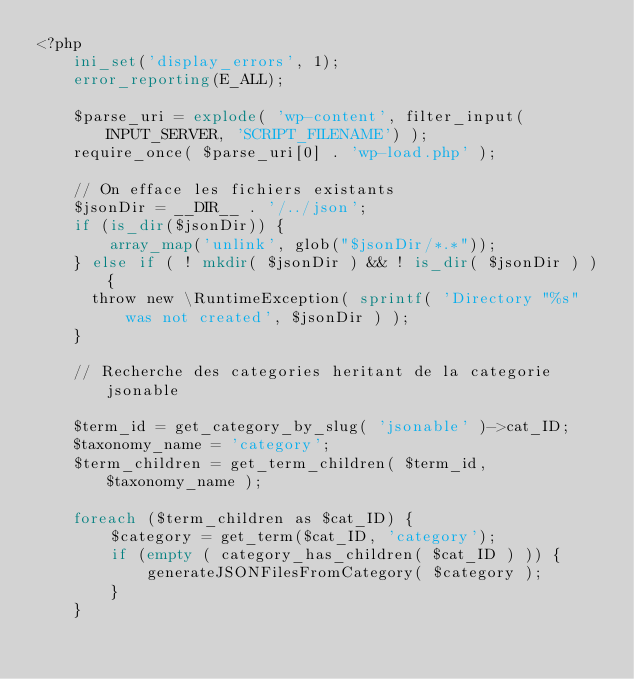Convert code to text. <code><loc_0><loc_0><loc_500><loc_500><_PHP_><?php
    ini_set('display_errors', 1);
    error_reporting(E_ALL);

    $parse_uri = explode( 'wp-content', filter_input(INPUT_SERVER, 'SCRIPT_FILENAME') );
    require_once( $parse_uri[0] . 'wp-load.php' );

    // On efface les fichiers existants
    $jsonDir = __DIR__ . '/../json';
    if (is_dir($jsonDir)) {
        array_map('unlink', glob("$jsonDir/*.*"));
    } else if ( ! mkdir( $jsonDir ) && ! is_dir( $jsonDir ) ) {
	    throw new \RuntimeException( sprintf( 'Directory "%s" was not created', $jsonDir ) );
    }

    // Recherche des categories heritant de la categorie jsonable

    $term_id = get_category_by_slug( 'jsonable' )->cat_ID;
    $taxonomy_name = 'category';
    $term_children = get_term_children( $term_id, $taxonomy_name );

    foreach ($term_children as $cat_ID) {
        $category = get_term($cat_ID, 'category');
        if (empty ( category_has_children( $cat_ID ) )) {
            generateJSONFilesFromCategory( $category );
        }
    }
</code> 